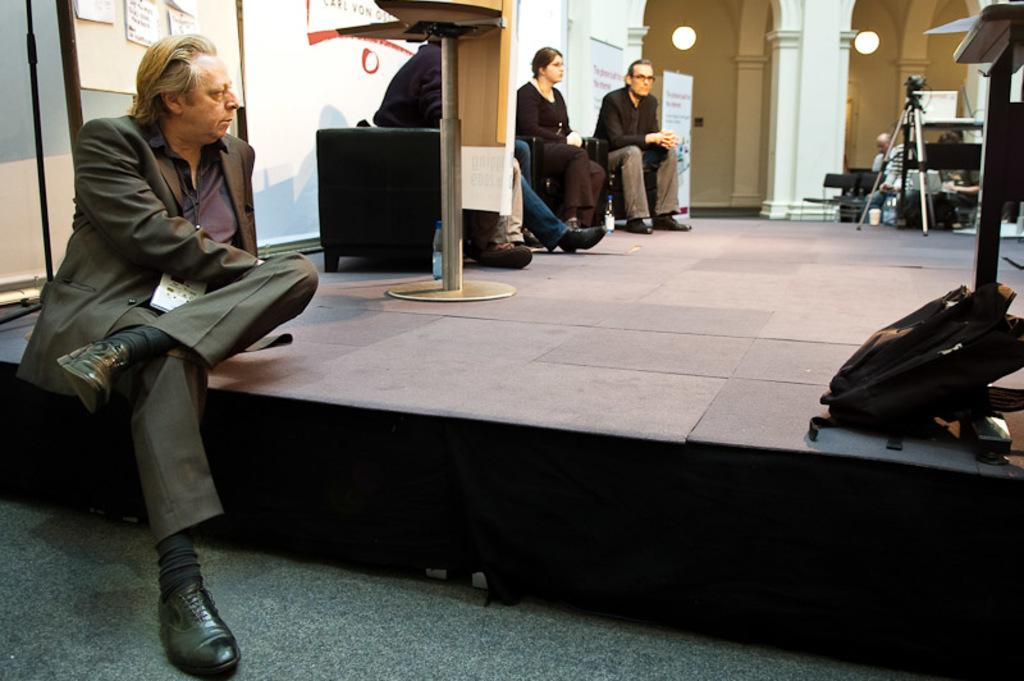What is the man in the image doing? The man is sitting on the floor. What are the people in the background doing? The people in the background are sitting in chairs. What equipment is visible in the image? There is a camera and a tripod in the image. What can be seen on the wall in the image? There is a wall pillar and a poster in the image. What type of cake is being served in the image? There is no cake present in the image. What room is the scene taking place in? The image does not provide enough information to determine the specific room where the scene is taking place. 